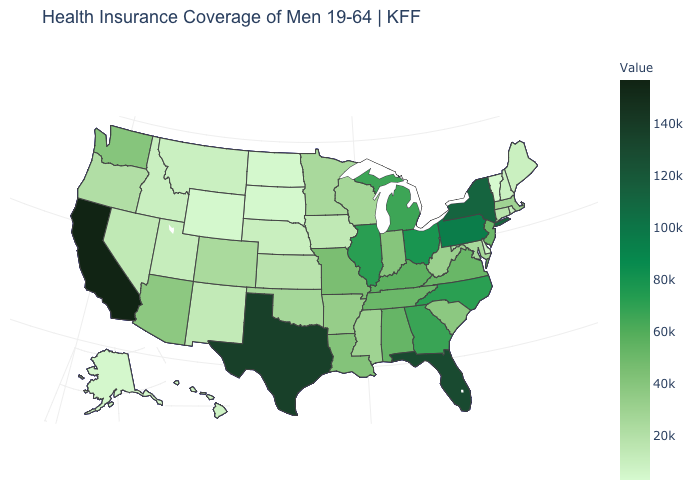Among the states that border Colorado , which have the lowest value?
Short answer required. Wyoming. Which states hav the highest value in the Northeast?
Give a very brief answer. New York. Does the map have missing data?
Keep it brief. No. Does the map have missing data?
Answer briefly. No. Does Oklahoma have a higher value than Wyoming?
Concise answer only. Yes. 